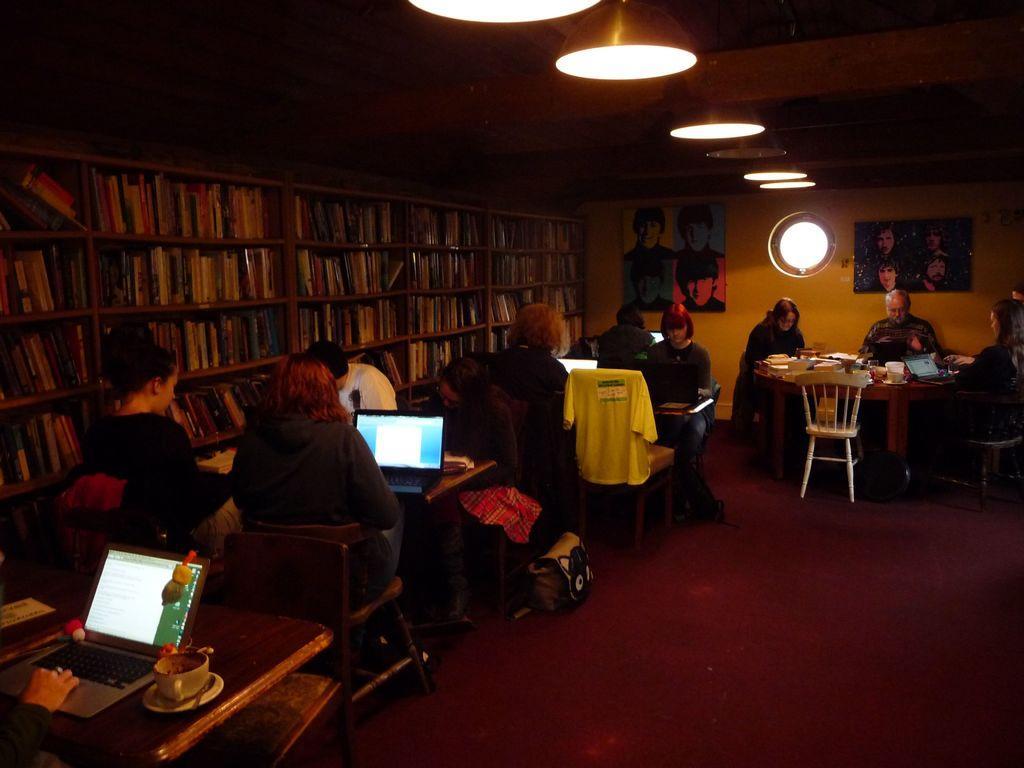In one or two sentences, can you explain what this image depicts? This is a library. Inside many people are sitting. and there are many tables and chairs. On the table there are cup, saucer, laptops, books. And people are working on laptops. In the background there is a cupboard with full of books. On the wall there are photo frames. On the ceiling there are lights. 